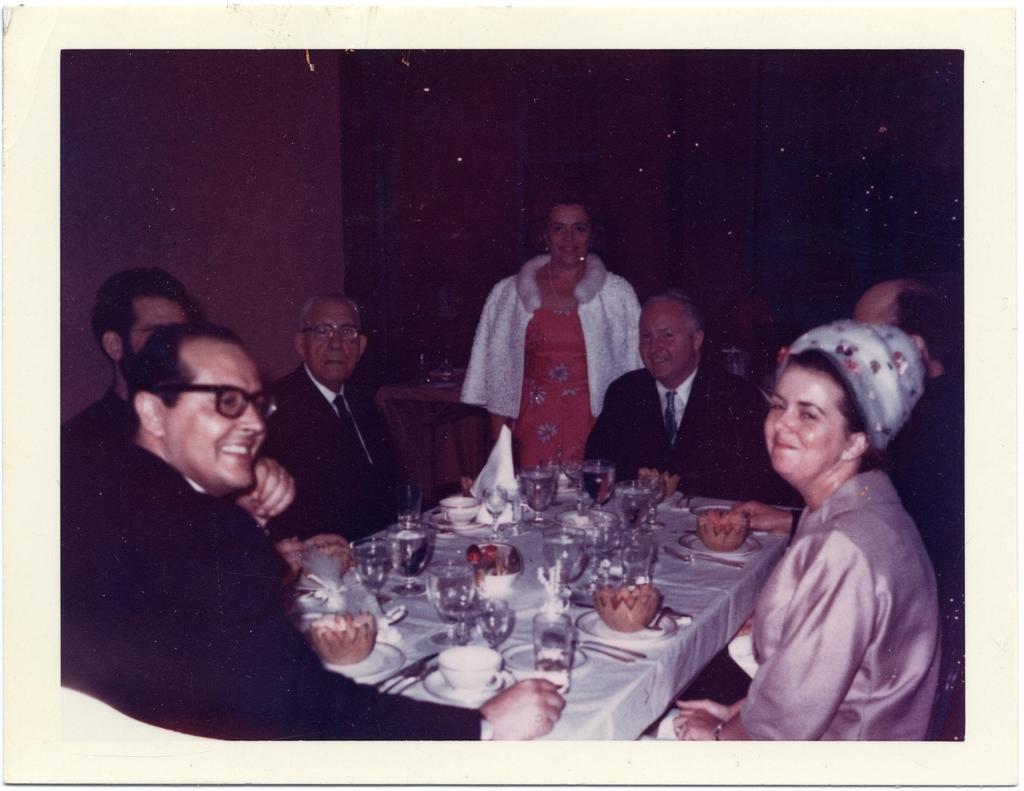Describe this image in one or two sentences. In this picture, we see people sitting on the chairs around the table. On the table, we see water glass, cup, sauce, spoon, fork, knife, plate containing food and tissue papers are placed. Behind them, we see a wall and in the background, it is dark. This picture is clicked in the dark. 